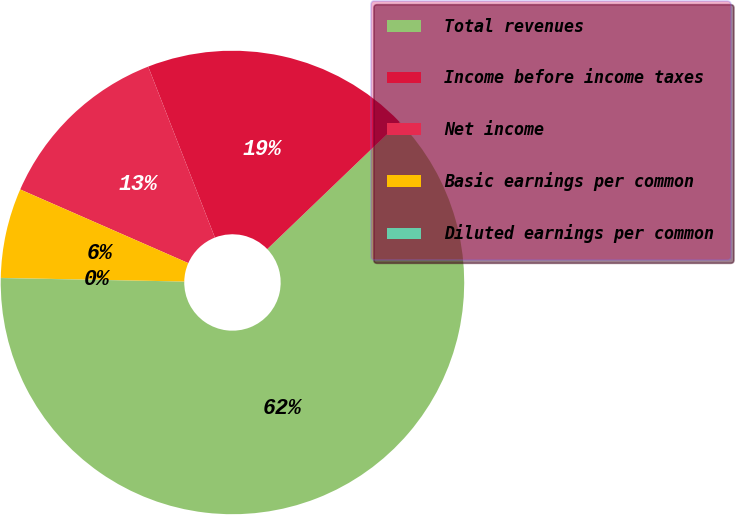Convert chart to OTSL. <chart><loc_0><loc_0><loc_500><loc_500><pie_chart><fcel>Total revenues<fcel>Income before income taxes<fcel>Net income<fcel>Basic earnings per common<fcel>Diluted earnings per common<nl><fcel>62.47%<fcel>18.75%<fcel>12.5%<fcel>6.26%<fcel>0.01%<nl></chart> 